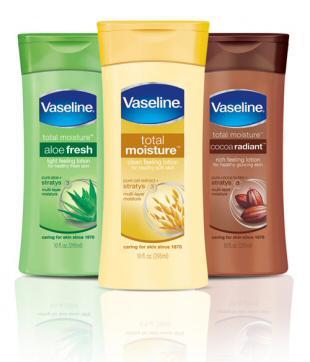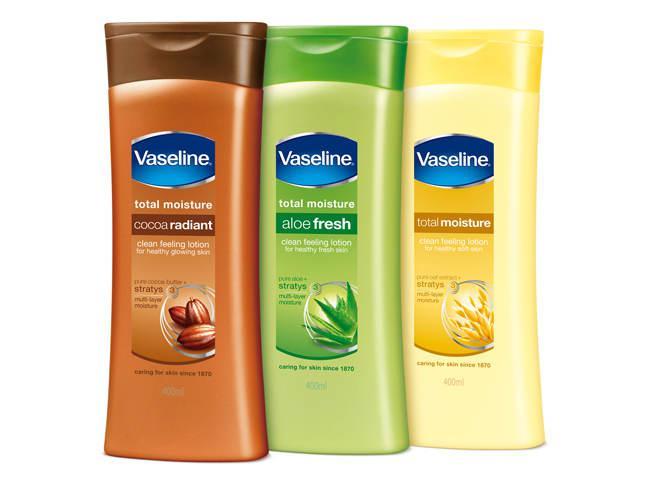The first image is the image on the left, the second image is the image on the right. Evaluate the accuracy of this statement regarding the images: "Lotions are in groups of three with flip-top lids.". Is it true? Answer yes or no. Yes. 